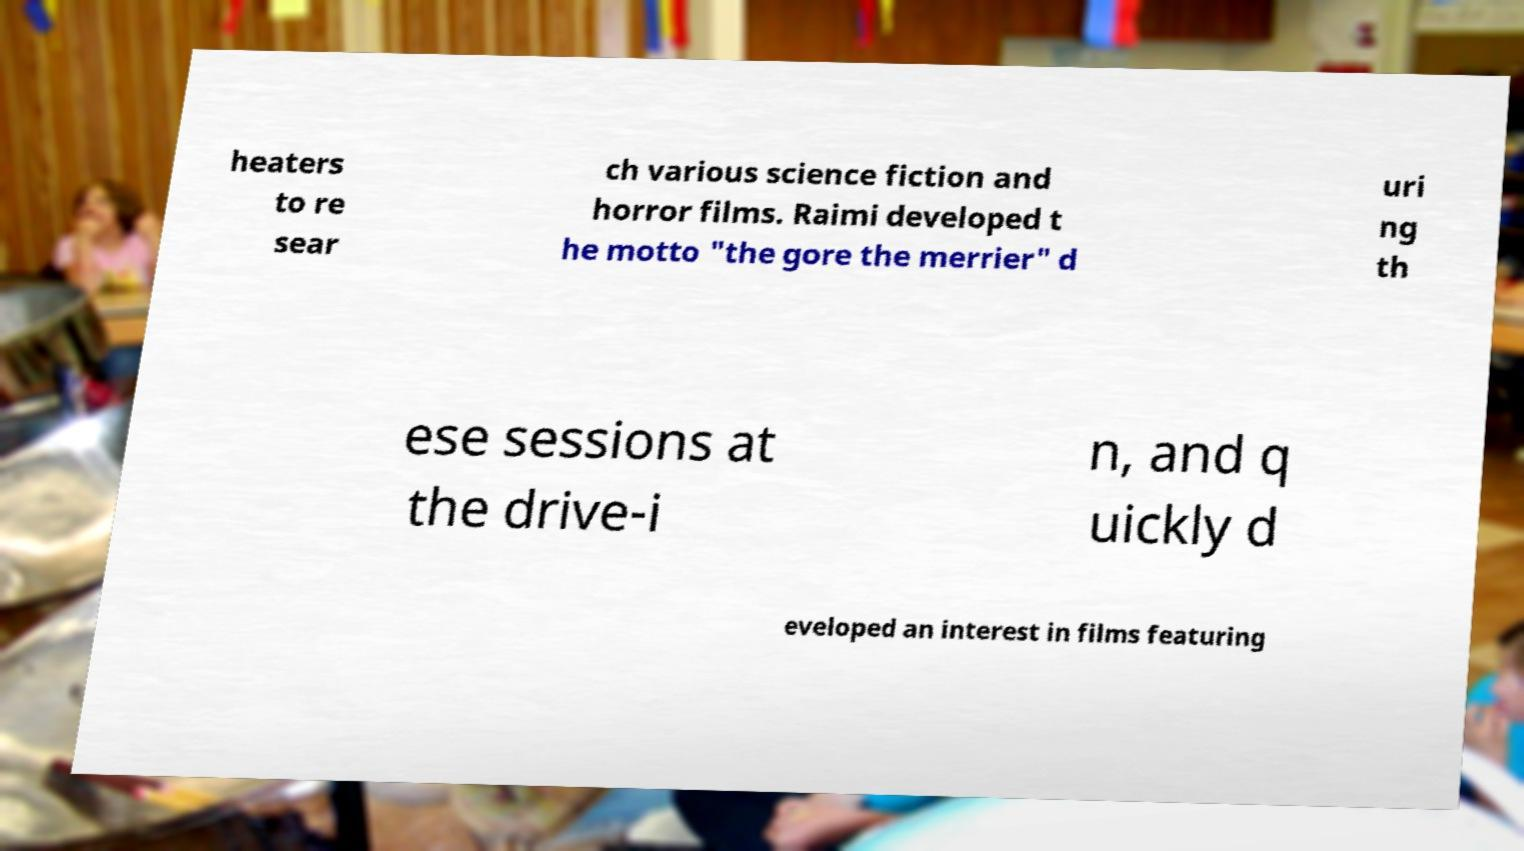For documentation purposes, I need the text within this image transcribed. Could you provide that? heaters to re sear ch various science fiction and horror films. Raimi developed t he motto "the gore the merrier" d uri ng th ese sessions at the drive-i n, and q uickly d eveloped an interest in films featuring 